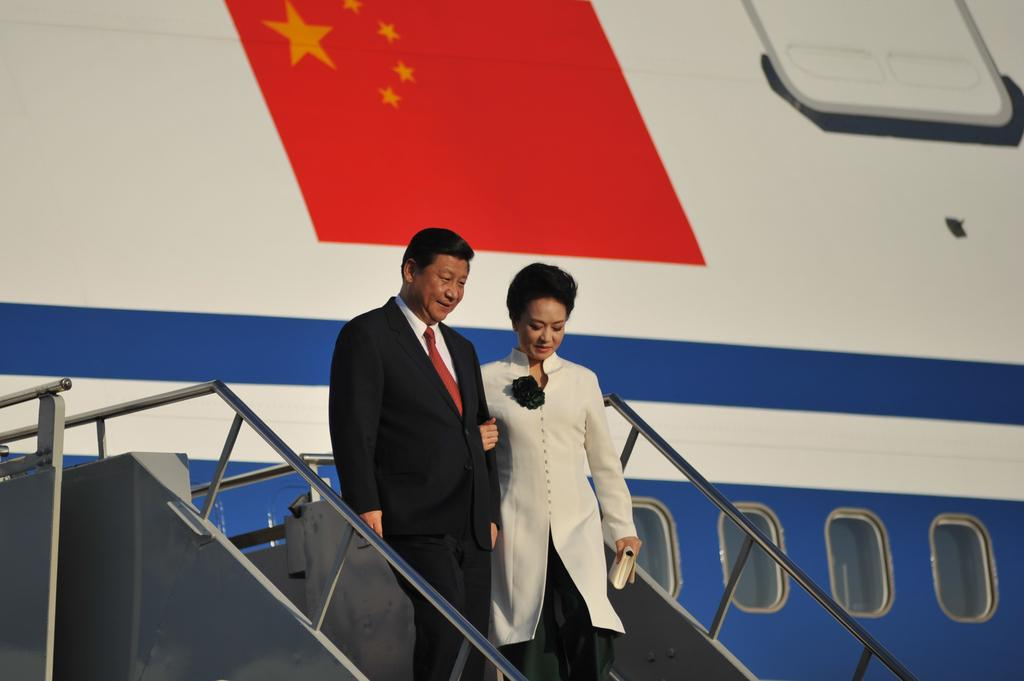What is the gender of the person in the image? There is a man in the image. What is the man doing in the image? The man is walking from a flight. What is the man wearing in the image? The man is wearing a black coat and black trousers. Can you describe the woman in the image? The woman is beautiful and wearing a coat. What is the woman holding in her left hand? The woman is holding a purse in her left hand. What type of shade does the man wish to find in the image? There is no mention of a shade or the man wishing for anything in the image. 